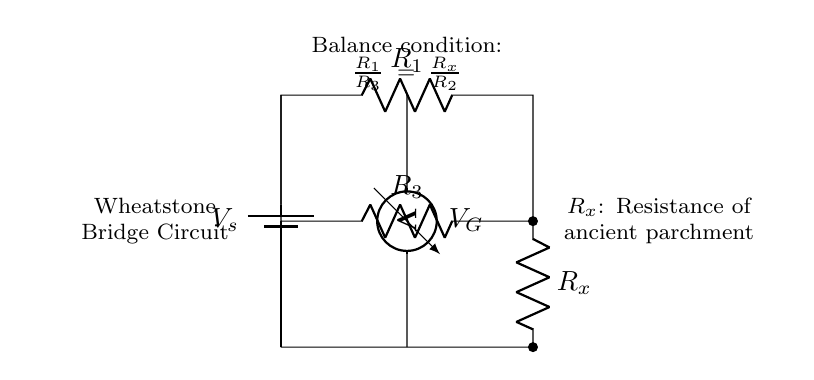What type of circuit is represented? The circuit shown is a Wheatstone Bridge, which is used to measure the unknown resistance by balancing two legs of a bridge circuit.
Answer: Wheatstone Bridge What is the function of R_x? R_x represents the unknown resistance of the ancient parchment that is being measured by the Wheatstone Bridge circuit.
Answer: Resistance of ancient parchment What is the balance condition of the circuit? The balance condition is given by the formula that states the ratio of resistances must be equal, specifically R_1 over R_3 equals R_x over R_2.
Answer: R_1/R_3 = R_x/R_2 Which component measures the voltage? The voltmeter in the circuit is the component that measures the voltage difference, specifically between the two points in the bridge.
Answer: Voltmeter How many resistors are in the circuit? There are four resistors in the Wheatstone Bridge circuit, including the unknown resistance R_x.
Answer: Four What is indicated by the term 'V_s'? 'V_s' denotes the source voltage applied across the Wheatstone Bridge, providing the necessary potential difference for the measurement to take place.
Answer: Source voltage What happens when the bridge is balanced? When the bridge is balanced, no current flows through the voltmeter, indicating that the ratios of the resistors are equal, and thus the unknown resistance can be calculated.
Answer: No current flows through the voltmeter 